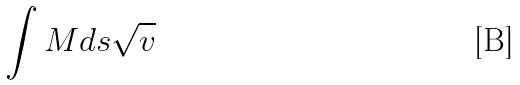Convert formula to latex. <formula><loc_0><loc_0><loc_500><loc_500>\int M d s \sqrt { v }</formula> 